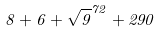<formula> <loc_0><loc_0><loc_500><loc_500>8 + 6 + \sqrt { 9 } ^ { 7 2 } + 2 9 0</formula> 